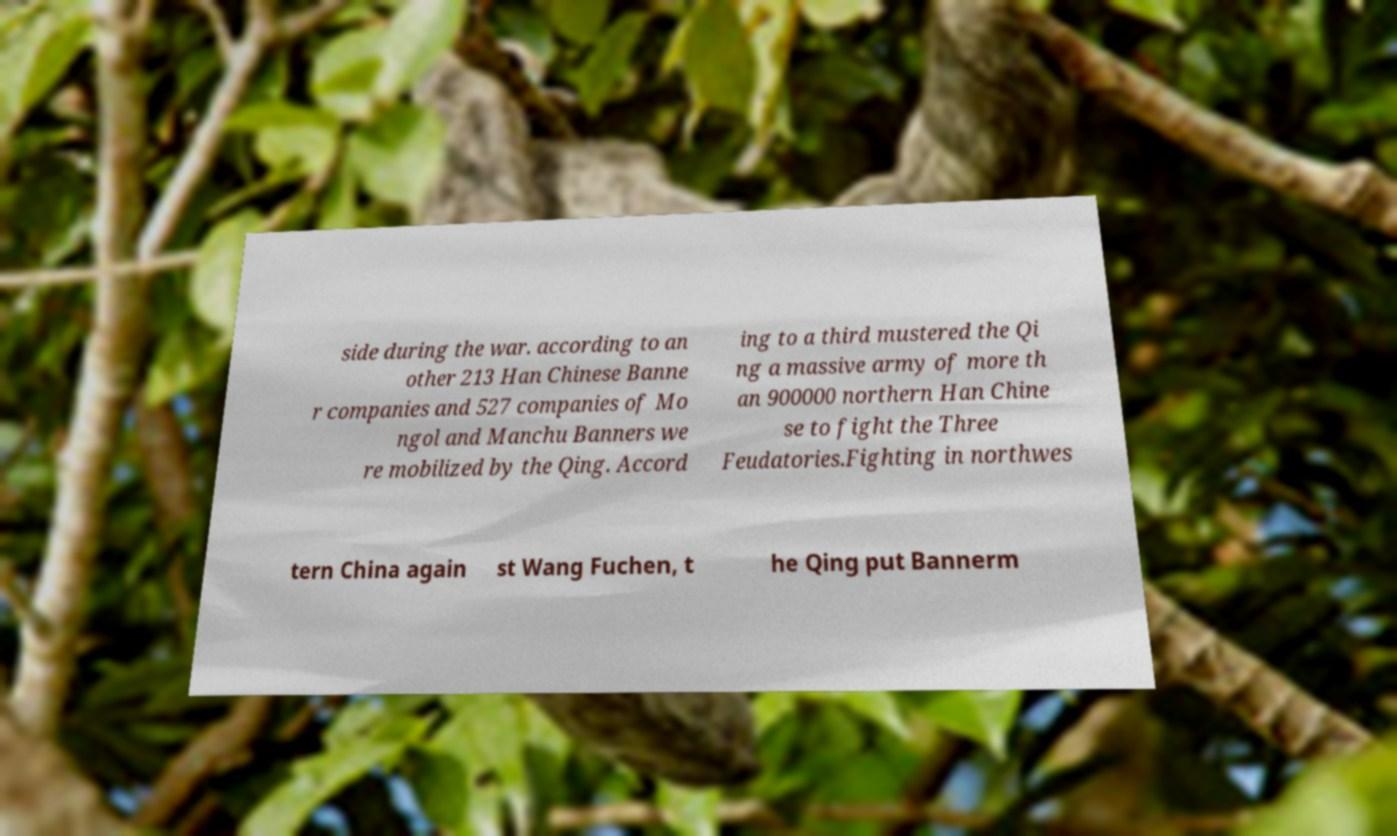Could you extract and type out the text from this image? side during the war. according to an other 213 Han Chinese Banne r companies and 527 companies of Mo ngol and Manchu Banners we re mobilized by the Qing. Accord ing to a third mustered the Qi ng a massive army of more th an 900000 northern Han Chine se to fight the Three Feudatories.Fighting in northwes tern China again st Wang Fuchen, t he Qing put Bannerm 